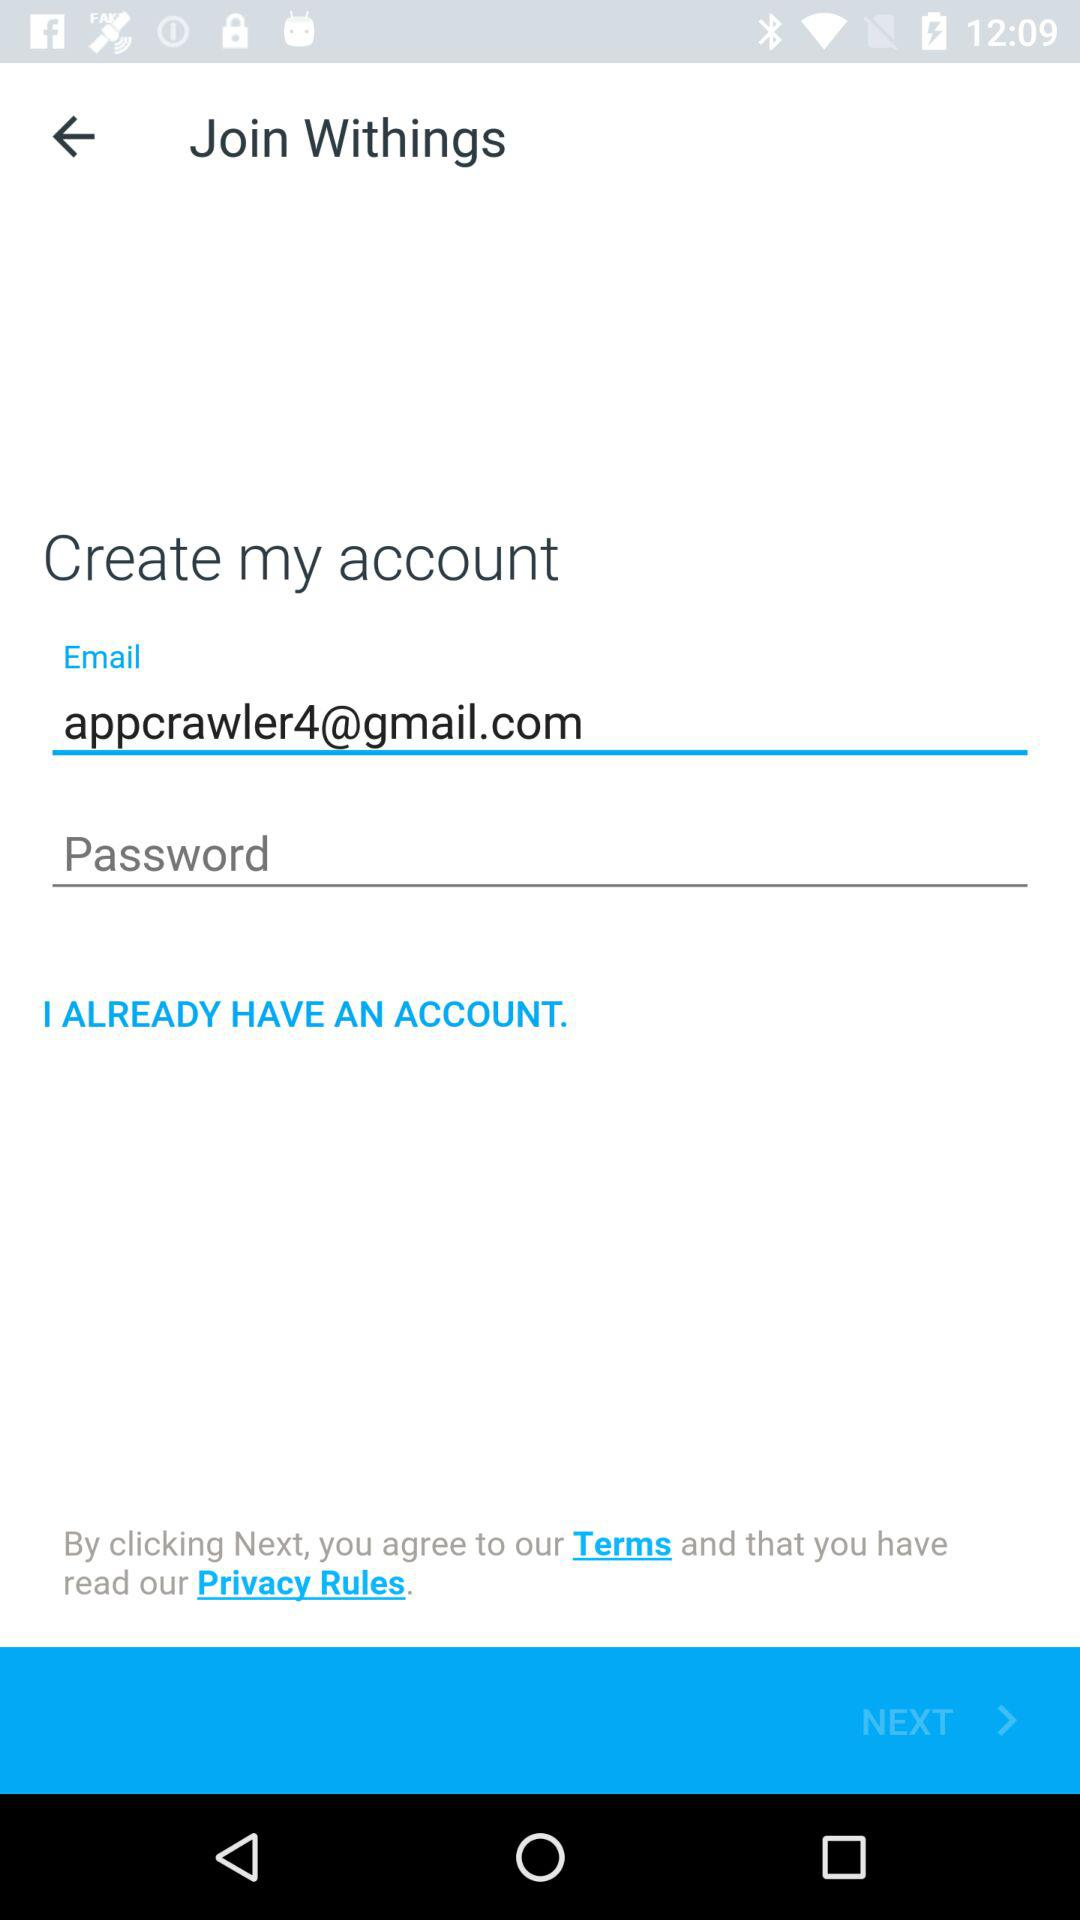What is the email address of the user? The email address of the user is appcrawler4@gmail.com. 